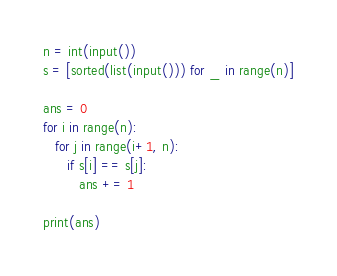<code> <loc_0><loc_0><loc_500><loc_500><_Python_>n = int(input())
s = [sorted(list(input())) for _ in range(n)]

ans = 0
for i in range(n):
   for j in range(i+1, n):
      if s[i] == s[j]:
         ans += 1

print(ans)
</code> 